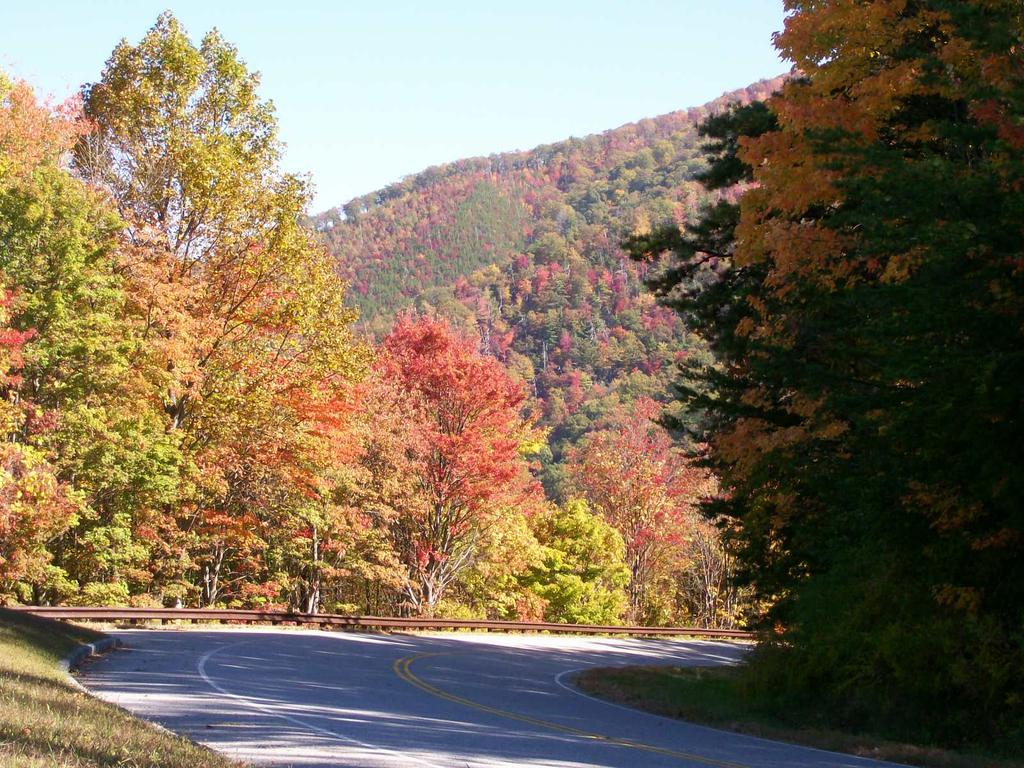What is the main feature in the foreground of the image? There is a road in the foreground of the image. What can be seen on both sides of the road? There are trees on either side of the road. What is visible in the background of the image? There are trees and the sky visible in the background of the image. How many legs can be seen on the trees in the image? Trees do not have legs, so this question cannot be answered based on the image. 